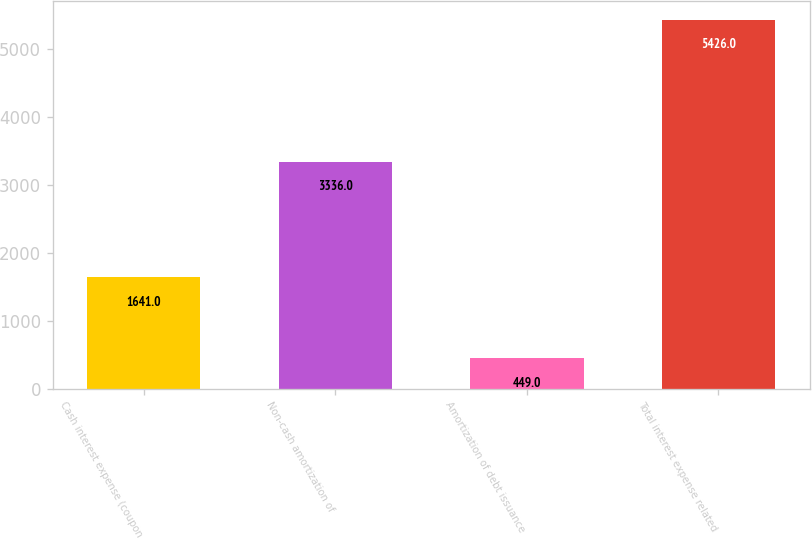<chart> <loc_0><loc_0><loc_500><loc_500><bar_chart><fcel>Cash interest expense (coupon<fcel>Non-cash amortization of<fcel>Amortization of debt issuance<fcel>Total interest expense related<nl><fcel>1641<fcel>3336<fcel>449<fcel>5426<nl></chart> 